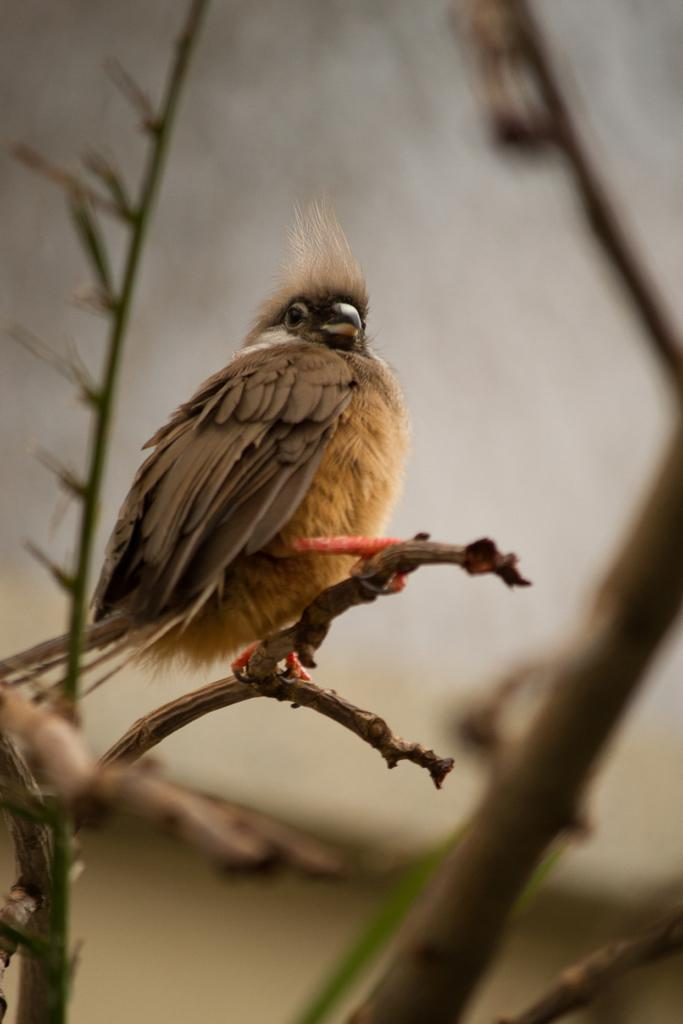What type of animal is in the image? There is a bird in the image. Where is the bird located in relation to the stem? The bird is sitting on a stem. Can you describe the bird's position in the image? The bird is in the middle of the image. What type of curtain is hanging near the bird in the image? There is no curtain present in the image; it features a bird sitting on a stem. 